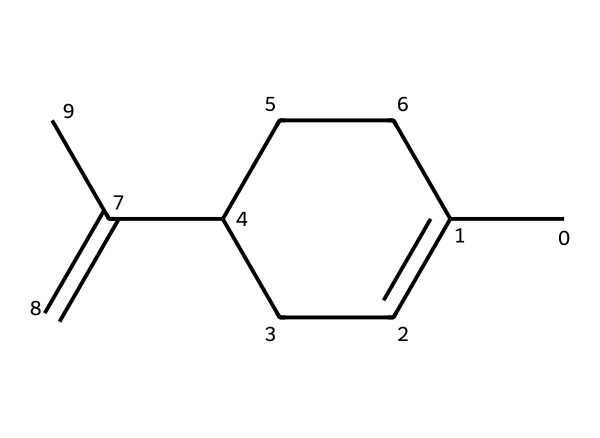how many carbon atoms are in limonene? In the provided SMILES representation, 'CC1=CCC(CC1)C(=C)C', we can count the number of 'C' symbols which represent carbon atoms. There are 10 carbon atoms in total.
Answer: 10 what is the functional group in limonene? The presence of a double bond (C=C) within the structure indicates that limonene is an alkene, which is a functional group characterized by carbon-carbon double bonds.
Answer: alkene how many hydrogen atoms are present in limonene? Carbon usually forms four bonds. By considering the structure and the number of double bonds and rings, we can account for the total hydrogen atoms. Limonene has 16 hydrogen atoms.
Answer: 16 does limonene contain any rings? The presence of 'C1' and 'C...' in the SMILES indicates a cyclic structure. Therefore, limonene does indeed contain a ring structure made of carbon atoms.
Answer: yes what type of compound is limonene classified as? The structure is a cycloalkene due to the ring structure and the presence of a double bond, which characterizes it as part of cycloalkanes with unsaturation.
Answer: cycloalkene how many double bonds are found in limonene? By analyzing the SMILES, we see one instance of a double bond indicated by '=' which confirms that there is a single double bond present in limonene.
Answer: 1 what type of geometric isomerism can limonene exhibit? Given the presence of a double bond in limonene, which restricts rotation, it can exhibit cis-trans isomerism based on the relative positions of substituents around the double bond.
Answer: cis-trans 